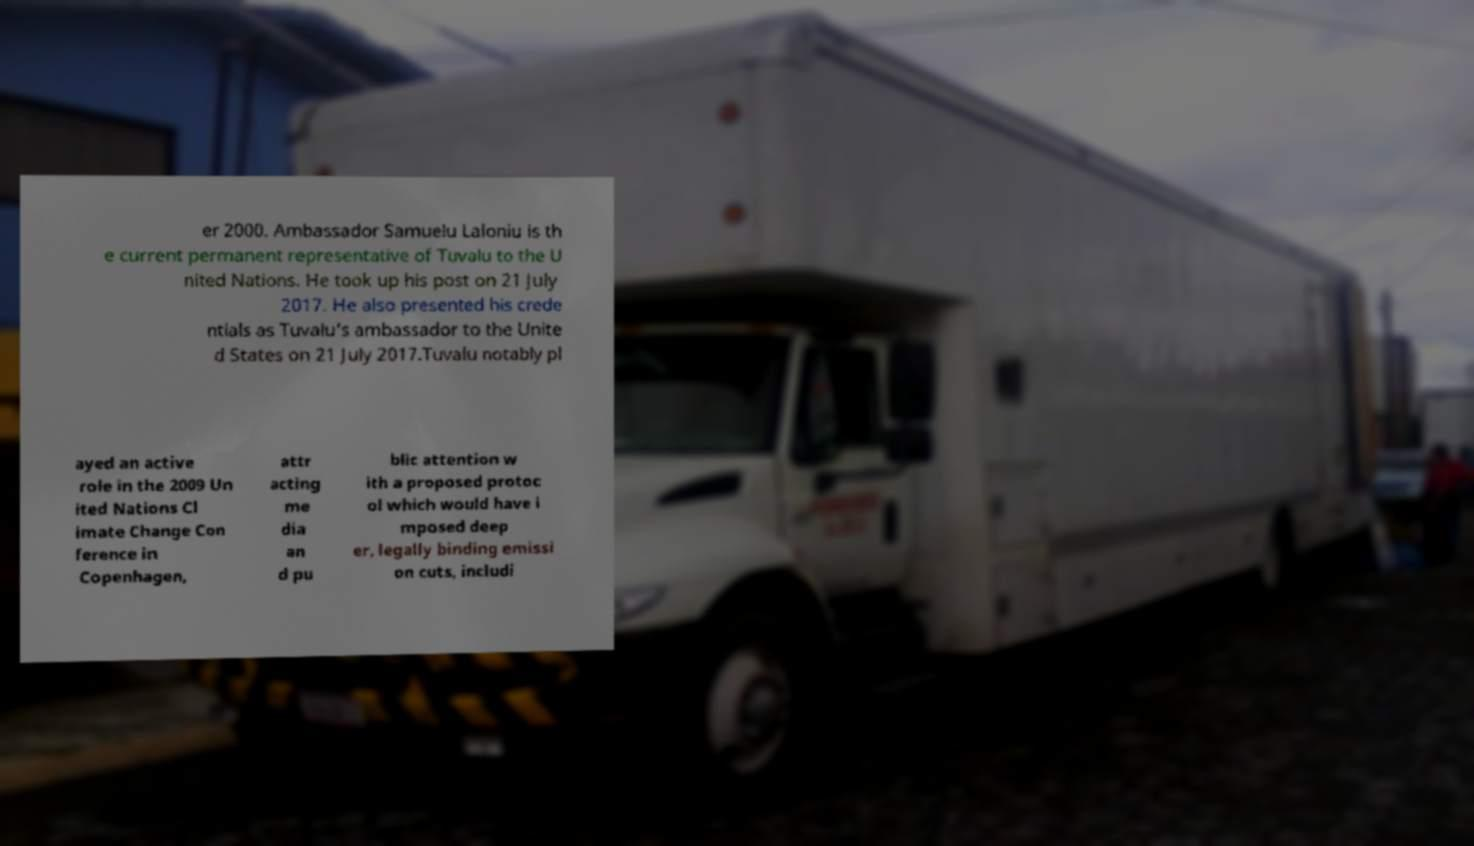I need the written content from this picture converted into text. Can you do that? er 2000. Ambassador Samuelu Laloniu is th e current permanent representative of Tuvalu to the U nited Nations. He took up his post on 21 July 2017. He also presented his crede ntials as Tuvalu's ambassador to the Unite d States on 21 July 2017.Tuvalu notably pl ayed an active role in the 2009 Un ited Nations Cl imate Change Con ference in Copenhagen, attr acting me dia an d pu blic attention w ith a proposed protoc ol which would have i mposed deep er, legally binding emissi on cuts, includi 